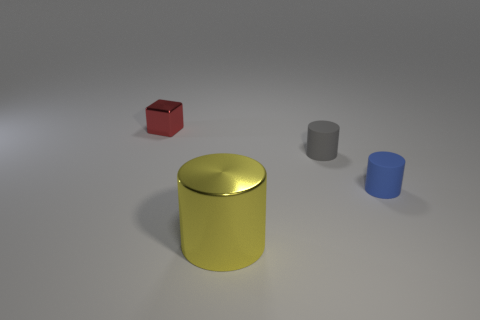Add 1 blue cubes. How many objects exist? 5 Subtract all blocks. How many objects are left? 3 Add 1 big purple rubber things. How many big purple rubber things exist? 1 Subtract 0 cyan cylinders. How many objects are left? 4 Subtract all large cyan rubber things. Subtract all gray matte cylinders. How many objects are left? 3 Add 1 matte cylinders. How many matte cylinders are left? 3 